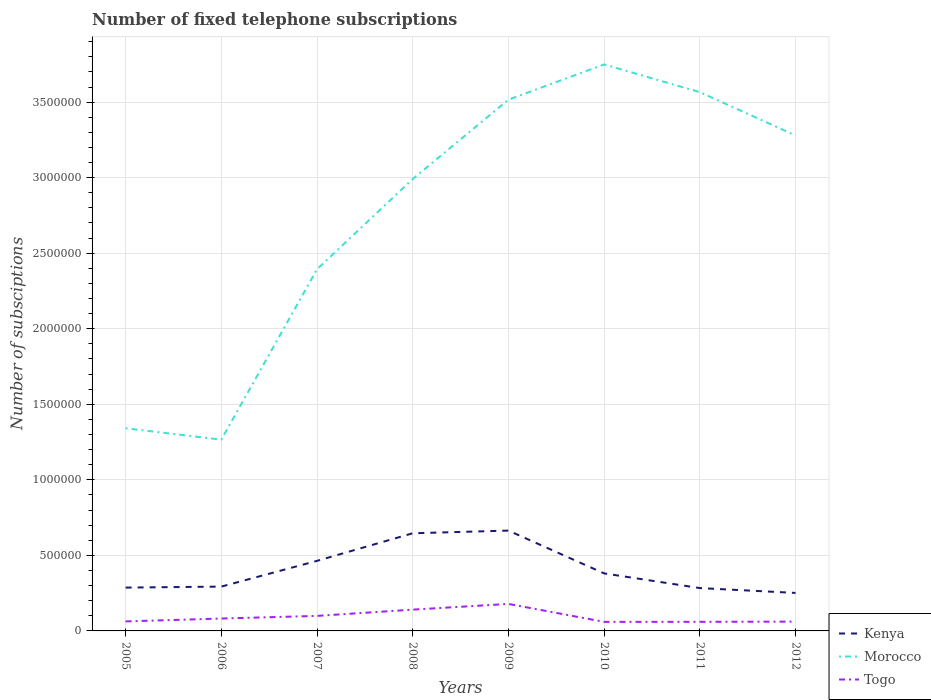Does the line corresponding to Kenya intersect with the line corresponding to Togo?
Keep it short and to the point. No. Is the number of lines equal to the number of legend labels?
Keep it short and to the point. Yes. Across all years, what is the maximum number of fixed telephone subscriptions in Morocco?
Offer a very short reply. 1.27e+06. What is the total number of fixed telephone subscriptions in Togo in the graph?
Your answer should be compact. -3.78e+04. What is the difference between the highest and the second highest number of fixed telephone subscriptions in Morocco?
Your answer should be very brief. 2.48e+06. What is the difference between the highest and the lowest number of fixed telephone subscriptions in Togo?
Your response must be concise. 3. Is the number of fixed telephone subscriptions in Kenya strictly greater than the number of fixed telephone subscriptions in Morocco over the years?
Offer a terse response. Yes. How many years are there in the graph?
Keep it short and to the point. 8. What is the difference between two consecutive major ticks on the Y-axis?
Offer a terse response. 5.00e+05. Does the graph contain any zero values?
Your response must be concise. No. How are the legend labels stacked?
Make the answer very short. Vertical. What is the title of the graph?
Your answer should be compact. Number of fixed telephone subscriptions. What is the label or title of the Y-axis?
Provide a short and direct response. Number of subsciptions. What is the Number of subsciptions in Kenya in 2005?
Provide a succinct answer. 2.87e+05. What is the Number of subsciptions in Morocco in 2005?
Offer a terse response. 1.34e+06. What is the Number of subsciptions in Togo in 2005?
Give a very brief answer. 6.28e+04. What is the Number of subsciptions of Kenya in 2006?
Offer a terse response. 2.93e+05. What is the Number of subsciptions in Morocco in 2006?
Provide a succinct answer. 1.27e+06. What is the Number of subsciptions of Togo in 2006?
Ensure brevity in your answer.  8.21e+04. What is the Number of subsciptions in Kenya in 2007?
Provide a short and direct response. 4.64e+05. What is the Number of subsciptions of Morocco in 2007?
Offer a very short reply. 2.39e+06. What is the Number of subsciptions in Togo in 2007?
Provide a short and direct response. 9.95e+04. What is the Number of subsciptions of Kenya in 2008?
Your answer should be very brief. 6.46e+05. What is the Number of subsciptions in Morocco in 2008?
Provide a short and direct response. 2.99e+06. What is the Number of subsciptions of Togo in 2008?
Your answer should be very brief. 1.41e+05. What is the Number of subsciptions in Kenya in 2009?
Offer a terse response. 6.64e+05. What is the Number of subsciptions in Morocco in 2009?
Your response must be concise. 3.52e+06. What is the Number of subsciptions in Togo in 2009?
Your answer should be compact. 1.79e+05. What is the Number of subsciptions in Kenya in 2010?
Provide a succinct answer. 3.81e+05. What is the Number of subsciptions in Morocco in 2010?
Your answer should be compact. 3.75e+06. What is the Number of subsciptions of Togo in 2010?
Give a very brief answer. 6.00e+04. What is the Number of subsciptions of Kenya in 2011?
Make the answer very short. 2.84e+05. What is the Number of subsciptions of Morocco in 2011?
Your answer should be very brief. 3.57e+06. What is the Number of subsciptions of Togo in 2011?
Your answer should be compact. 6.03e+04. What is the Number of subsciptions in Kenya in 2012?
Give a very brief answer. 2.52e+05. What is the Number of subsciptions of Morocco in 2012?
Provide a short and direct response. 3.28e+06. What is the Number of subsciptions of Togo in 2012?
Offer a terse response. 6.16e+04. Across all years, what is the maximum Number of subsciptions in Kenya?
Make the answer very short. 6.64e+05. Across all years, what is the maximum Number of subsciptions of Morocco?
Provide a short and direct response. 3.75e+06. Across all years, what is the maximum Number of subsciptions of Togo?
Provide a succinct answer. 1.79e+05. Across all years, what is the minimum Number of subsciptions of Kenya?
Provide a succinct answer. 2.52e+05. Across all years, what is the minimum Number of subsciptions in Morocco?
Provide a short and direct response. 1.27e+06. Across all years, what is the minimum Number of subsciptions of Togo?
Your answer should be very brief. 6.00e+04. What is the total Number of subsciptions of Kenya in the graph?
Keep it short and to the point. 3.27e+06. What is the total Number of subsciptions of Morocco in the graph?
Your answer should be very brief. 2.21e+07. What is the total Number of subsciptions of Togo in the graph?
Ensure brevity in your answer.  7.46e+05. What is the difference between the Number of subsciptions of Kenya in 2005 and that in 2006?
Provide a succinct answer. -6635. What is the difference between the Number of subsciptions of Morocco in 2005 and that in 2006?
Give a very brief answer. 7.50e+04. What is the difference between the Number of subsciptions in Togo in 2005 and that in 2006?
Provide a succinct answer. -1.92e+04. What is the difference between the Number of subsciptions in Kenya in 2005 and that in 2007?
Give a very brief answer. -1.77e+05. What is the difference between the Number of subsciptions of Morocco in 2005 and that in 2007?
Keep it short and to the point. -1.05e+06. What is the difference between the Number of subsciptions in Togo in 2005 and that in 2007?
Provide a succinct answer. -3.67e+04. What is the difference between the Number of subsciptions in Kenya in 2005 and that in 2008?
Provide a short and direct response. -3.60e+05. What is the difference between the Number of subsciptions of Morocco in 2005 and that in 2008?
Make the answer very short. -1.65e+06. What is the difference between the Number of subsciptions of Togo in 2005 and that in 2008?
Your response must be concise. -7.81e+04. What is the difference between the Number of subsciptions in Kenya in 2005 and that in 2009?
Offer a very short reply. -3.77e+05. What is the difference between the Number of subsciptions in Morocco in 2005 and that in 2009?
Provide a short and direct response. -2.18e+06. What is the difference between the Number of subsciptions of Togo in 2005 and that in 2009?
Offer a very short reply. -1.16e+05. What is the difference between the Number of subsciptions in Kenya in 2005 and that in 2010?
Your response must be concise. -9.40e+04. What is the difference between the Number of subsciptions in Morocco in 2005 and that in 2010?
Your answer should be compact. -2.41e+06. What is the difference between the Number of subsciptions in Togo in 2005 and that in 2010?
Your answer should be compact. 2820. What is the difference between the Number of subsciptions of Kenya in 2005 and that in 2011?
Your answer should be compact. 3183. What is the difference between the Number of subsciptions of Morocco in 2005 and that in 2011?
Provide a succinct answer. -2.22e+06. What is the difference between the Number of subsciptions in Togo in 2005 and that in 2011?
Provide a short and direct response. 2558. What is the difference between the Number of subsciptions of Kenya in 2005 and that in 2012?
Your answer should be compact. 3.52e+04. What is the difference between the Number of subsciptions in Morocco in 2005 and that in 2012?
Your response must be concise. -1.94e+06. What is the difference between the Number of subsciptions of Togo in 2005 and that in 2012?
Provide a succinct answer. 1241. What is the difference between the Number of subsciptions of Kenya in 2006 and that in 2007?
Your answer should be very brief. -1.70e+05. What is the difference between the Number of subsciptions in Morocco in 2006 and that in 2007?
Your answer should be very brief. -1.13e+06. What is the difference between the Number of subsciptions of Togo in 2006 and that in 2007?
Make the answer very short. -1.74e+04. What is the difference between the Number of subsciptions of Kenya in 2006 and that in 2008?
Offer a very short reply. -3.53e+05. What is the difference between the Number of subsciptions of Morocco in 2006 and that in 2008?
Your answer should be compact. -1.73e+06. What is the difference between the Number of subsciptions of Togo in 2006 and that in 2008?
Offer a very short reply. -5.89e+04. What is the difference between the Number of subsciptions of Kenya in 2006 and that in 2009?
Your answer should be compact. -3.71e+05. What is the difference between the Number of subsciptions of Morocco in 2006 and that in 2009?
Your answer should be very brief. -2.25e+06. What is the difference between the Number of subsciptions of Togo in 2006 and that in 2009?
Ensure brevity in your answer.  -9.67e+04. What is the difference between the Number of subsciptions in Kenya in 2006 and that in 2010?
Keep it short and to the point. -8.74e+04. What is the difference between the Number of subsciptions in Morocco in 2006 and that in 2010?
Keep it short and to the point. -2.48e+06. What is the difference between the Number of subsciptions of Togo in 2006 and that in 2010?
Give a very brief answer. 2.20e+04. What is the difference between the Number of subsciptions in Kenya in 2006 and that in 2011?
Ensure brevity in your answer.  9818. What is the difference between the Number of subsciptions in Morocco in 2006 and that in 2011?
Your response must be concise. -2.30e+06. What is the difference between the Number of subsciptions of Togo in 2006 and that in 2011?
Provide a short and direct response. 2.18e+04. What is the difference between the Number of subsciptions in Kenya in 2006 and that in 2012?
Offer a terse response. 4.18e+04. What is the difference between the Number of subsciptions of Morocco in 2006 and that in 2012?
Ensure brevity in your answer.  -2.01e+06. What is the difference between the Number of subsciptions of Togo in 2006 and that in 2012?
Give a very brief answer. 2.05e+04. What is the difference between the Number of subsciptions of Kenya in 2007 and that in 2008?
Give a very brief answer. -1.83e+05. What is the difference between the Number of subsciptions of Morocco in 2007 and that in 2008?
Your response must be concise. -5.97e+05. What is the difference between the Number of subsciptions in Togo in 2007 and that in 2008?
Offer a terse response. -4.14e+04. What is the difference between the Number of subsciptions in Kenya in 2007 and that in 2009?
Keep it short and to the point. -2.00e+05. What is the difference between the Number of subsciptions of Morocco in 2007 and that in 2009?
Your response must be concise. -1.12e+06. What is the difference between the Number of subsciptions in Togo in 2007 and that in 2009?
Your answer should be compact. -7.92e+04. What is the difference between the Number of subsciptions in Kenya in 2007 and that in 2010?
Your answer should be compact. 8.30e+04. What is the difference between the Number of subsciptions of Morocco in 2007 and that in 2010?
Provide a short and direct response. -1.36e+06. What is the difference between the Number of subsciptions of Togo in 2007 and that in 2010?
Your response must be concise. 3.95e+04. What is the difference between the Number of subsciptions of Kenya in 2007 and that in 2011?
Offer a very short reply. 1.80e+05. What is the difference between the Number of subsciptions of Morocco in 2007 and that in 2011?
Your answer should be very brief. -1.17e+06. What is the difference between the Number of subsciptions of Togo in 2007 and that in 2011?
Keep it short and to the point. 3.92e+04. What is the difference between the Number of subsciptions of Kenya in 2007 and that in 2012?
Your response must be concise. 2.12e+05. What is the difference between the Number of subsciptions in Morocco in 2007 and that in 2012?
Provide a short and direct response. -8.85e+05. What is the difference between the Number of subsciptions in Togo in 2007 and that in 2012?
Your response must be concise. 3.79e+04. What is the difference between the Number of subsciptions in Kenya in 2008 and that in 2009?
Your response must be concise. -1.77e+04. What is the difference between the Number of subsciptions of Morocco in 2008 and that in 2009?
Provide a succinct answer. -5.25e+05. What is the difference between the Number of subsciptions in Togo in 2008 and that in 2009?
Offer a very short reply. -3.78e+04. What is the difference between the Number of subsciptions of Kenya in 2008 and that in 2010?
Offer a very short reply. 2.66e+05. What is the difference between the Number of subsciptions in Morocco in 2008 and that in 2010?
Provide a succinct answer. -7.58e+05. What is the difference between the Number of subsciptions of Togo in 2008 and that in 2010?
Your answer should be very brief. 8.09e+04. What is the difference between the Number of subsciptions in Kenya in 2008 and that in 2011?
Your response must be concise. 3.63e+05. What is the difference between the Number of subsciptions of Morocco in 2008 and that in 2011?
Give a very brief answer. -5.75e+05. What is the difference between the Number of subsciptions in Togo in 2008 and that in 2011?
Give a very brief answer. 8.06e+04. What is the difference between the Number of subsciptions in Kenya in 2008 and that in 2012?
Offer a very short reply. 3.95e+05. What is the difference between the Number of subsciptions in Morocco in 2008 and that in 2012?
Offer a terse response. -2.88e+05. What is the difference between the Number of subsciptions in Togo in 2008 and that in 2012?
Your answer should be compact. 7.93e+04. What is the difference between the Number of subsciptions of Kenya in 2009 and that in 2010?
Ensure brevity in your answer.  2.83e+05. What is the difference between the Number of subsciptions of Morocco in 2009 and that in 2010?
Keep it short and to the point. -2.33e+05. What is the difference between the Number of subsciptions of Togo in 2009 and that in 2010?
Offer a terse response. 1.19e+05. What is the difference between the Number of subsciptions of Kenya in 2009 and that in 2011?
Keep it short and to the point. 3.81e+05. What is the difference between the Number of subsciptions in Morocco in 2009 and that in 2011?
Ensure brevity in your answer.  -4.98e+04. What is the difference between the Number of subsciptions of Togo in 2009 and that in 2011?
Your answer should be compact. 1.18e+05. What is the difference between the Number of subsciptions in Kenya in 2009 and that in 2012?
Provide a succinct answer. 4.13e+05. What is the difference between the Number of subsciptions in Morocco in 2009 and that in 2012?
Provide a short and direct response. 2.37e+05. What is the difference between the Number of subsciptions of Togo in 2009 and that in 2012?
Ensure brevity in your answer.  1.17e+05. What is the difference between the Number of subsciptions of Kenya in 2010 and that in 2011?
Give a very brief answer. 9.72e+04. What is the difference between the Number of subsciptions in Morocco in 2010 and that in 2011?
Offer a terse response. 1.83e+05. What is the difference between the Number of subsciptions in Togo in 2010 and that in 2011?
Offer a terse response. -262. What is the difference between the Number of subsciptions of Kenya in 2010 and that in 2012?
Offer a terse response. 1.29e+05. What is the difference between the Number of subsciptions in Morocco in 2010 and that in 2012?
Offer a very short reply. 4.70e+05. What is the difference between the Number of subsciptions of Togo in 2010 and that in 2012?
Your answer should be very brief. -1579. What is the difference between the Number of subsciptions of Kenya in 2011 and that in 2012?
Offer a very short reply. 3.20e+04. What is the difference between the Number of subsciptions of Morocco in 2011 and that in 2012?
Offer a terse response. 2.87e+05. What is the difference between the Number of subsciptions in Togo in 2011 and that in 2012?
Provide a succinct answer. -1317. What is the difference between the Number of subsciptions in Kenya in 2005 and the Number of subsciptions in Morocco in 2006?
Give a very brief answer. -9.79e+05. What is the difference between the Number of subsciptions in Kenya in 2005 and the Number of subsciptions in Togo in 2006?
Offer a terse response. 2.05e+05. What is the difference between the Number of subsciptions in Morocco in 2005 and the Number of subsciptions in Togo in 2006?
Your response must be concise. 1.26e+06. What is the difference between the Number of subsciptions in Kenya in 2005 and the Number of subsciptions in Morocco in 2007?
Provide a short and direct response. -2.11e+06. What is the difference between the Number of subsciptions in Kenya in 2005 and the Number of subsciptions in Togo in 2007?
Make the answer very short. 1.87e+05. What is the difference between the Number of subsciptions of Morocco in 2005 and the Number of subsciptions of Togo in 2007?
Make the answer very short. 1.24e+06. What is the difference between the Number of subsciptions of Kenya in 2005 and the Number of subsciptions of Morocco in 2008?
Your response must be concise. -2.70e+06. What is the difference between the Number of subsciptions in Kenya in 2005 and the Number of subsciptions in Togo in 2008?
Provide a succinct answer. 1.46e+05. What is the difference between the Number of subsciptions in Morocco in 2005 and the Number of subsciptions in Togo in 2008?
Offer a terse response. 1.20e+06. What is the difference between the Number of subsciptions in Kenya in 2005 and the Number of subsciptions in Morocco in 2009?
Give a very brief answer. -3.23e+06. What is the difference between the Number of subsciptions of Kenya in 2005 and the Number of subsciptions of Togo in 2009?
Ensure brevity in your answer.  1.08e+05. What is the difference between the Number of subsciptions in Morocco in 2005 and the Number of subsciptions in Togo in 2009?
Keep it short and to the point. 1.16e+06. What is the difference between the Number of subsciptions of Kenya in 2005 and the Number of subsciptions of Morocco in 2010?
Your response must be concise. -3.46e+06. What is the difference between the Number of subsciptions in Kenya in 2005 and the Number of subsciptions in Togo in 2010?
Your answer should be compact. 2.27e+05. What is the difference between the Number of subsciptions in Morocco in 2005 and the Number of subsciptions in Togo in 2010?
Ensure brevity in your answer.  1.28e+06. What is the difference between the Number of subsciptions of Kenya in 2005 and the Number of subsciptions of Morocco in 2011?
Make the answer very short. -3.28e+06. What is the difference between the Number of subsciptions of Kenya in 2005 and the Number of subsciptions of Togo in 2011?
Offer a very short reply. 2.26e+05. What is the difference between the Number of subsciptions of Morocco in 2005 and the Number of subsciptions of Togo in 2011?
Offer a very short reply. 1.28e+06. What is the difference between the Number of subsciptions of Kenya in 2005 and the Number of subsciptions of Morocco in 2012?
Make the answer very short. -2.99e+06. What is the difference between the Number of subsciptions of Kenya in 2005 and the Number of subsciptions of Togo in 2012?
Your answer should be compact. 2.25e+05. What is the difference between the Number of subsciptions in Morocco in 2005 and the Number of subsciptions in Togo in 2012?
Keep it short and to the point. 1.28e+06. What is the difference between the Number of subsciptions in Kenya in 2006 and the Number of subsciptions in Morocco in 2007?
Your response must be concise. -2.10e+06. What is the difference between the Number of subsciptions in Kenya in 2006 and the Number of subsciptions in Togo in 2007?
Offer a terse response. 1.94e+05. What is the difference between the Number of subsciptions in Morocco in 2006 and the Number of subsciptions in Togo in 2007?
Ensure brevity in your answer.  1.17e+06. What is the difference between the Number of subsciptions in Kenya in 2006 and the Number of subsciptions in Morocco in 2008?
Offer a terse response. -2.70e+06. What is the difference between the Number of subsciptions of Kenya in 2006 and the Number of subsciptions of Togo in 2008?
Offer a terse response. 1.52e+05. What is the difference between the Number of subsciptions of Morocco in 2006 and the Number of subsciptions of Togo in 2008?
Offer a very short reply. 1.13e+06. What is the difference between the Number of subsciptions in Kenya in 2006 and the Number of subsciptions in Morocco in 2009?
Your answer should be compact. -3.22e+06. What is the difference between the Number of subsciptions of Kenya in 2006 and the Number of subsciptions of Togo in 2009?
Offer a terse response. 1.15e+05. What is the difference between the Number of subsciptions in Morocco in 2006 and the Number of subsciptions in Togo in 2009?
Your answer should be very brief. 1.09e+06. What is the difference between the Number of subsciptions of Kenya in 2006 and the Number of subsciptions of Morocco in 2010?
Your response must be concise. -3.46e+06. What is the difference between the Number of subsciptions of Kenya in 2006 and the Number of subsciptions of Togo in 2010?
Your answer should be compact. 2.33e+05. What is the difference between the Number of subsciptions of Morocco in 2006 and the Number of subsciptions of Togo in 2010?
Give a very brief answer. 1.21e+06. What is the difference between the Number of subsciptions of Kenya in 2006 and the Number of subsciptions of Morocco in 2011?
Ensure brevity in your answer.  -3.27e+06. What is the difference between the Number of subsciptions of Kenya in 2006 and the Number of subsciptions of Togo in 2011?
Your response must be concise. 2.33e+05. What is the difference between the Number of subsciptions of Morocco in 2006 and the Number of subsciptions of Togo in 2011?
Offer a very short reply. 1.21e+06. What is the difference between the Number of subsciptions in Kenya in 2006 and the Number of subsciptions in Morocco in 2012?
Provide a succinct answer. -2.99e+06. What is the difference between the Number of subsciptions in Kenya in 2006 and the Number of subsciptions in Togo in 2012?
Provide a succinct answer. 2.32e+05. What is the difference between the Number of subsciptions in Morocco in 2006 and the Number of subsciptions in Togo in 2012?
Give a very brief answer. 1.20e+06. What is the difference between the Number of subsciptions of Kenya in 2007 and the Number of subsciptions of Morocco in 2008?
Your answer should be compact. -2.53e+06. What is the difference between the Number of subsciptions of Kenya in 2007 and the Number of subsciptions of Togo in 2008?
Keep it short and to the point. 3.23e+05. What is the difference between the Number of subsciptions in Morocco in 2007 and the Number of subsciptions in Togo in 2008?
Ensure brevity in your answer.  2.25e+06. What is the difference between the Number of subsciptions in Kenya in 2007 and the Number of subsciptions in Morocco in 2009?
Provide a succinct answer. -3.05e+06. What is the difference between the Number of subsciptions in Kenya in 2007 and the Number of subsciptions in Togo in 2009?
Your answer should be compact. 2.85e+05. What is the difference between the Number of subsciptions of Morocco in 2007 and the Number of subsciptions of Togo in 2009?
Your response must be concise. 2.22e+06. What is the difference between the Number of subsciptions in Kenya in 2007 and the Number of subsciptions in Morocco in 2010?
Give a very brief answer. -3.29e+06. What is the difference between the Number of subsciptions in Kenya in 2007 and the Number of subsciptions in Togo in 2010?
Offer a terse response. 4.04e+05. What is the difference between the Number of subsciptions in Morocco in 2007 and the Number of subsciptions in Togo in 2010?
Keep it short and to the point. 2.33e+06. What is the difference between the Number of subsciptions in Kenya in 2007 and the Number of subsciptions in Morocco in 2011?
Provide a succinct answer. -3.10e+06. What is the difference between the Number of subsciptions of Kenya in 2007 and the Number of subsciptions of Togo in 2011?
Your answer should be compact. 4.03e+05. What is the difference between the Number of subsciptions in Morocco in 2007 and the Number of subsciptions in Togo in 2011?
Your answer should be compact. 2.33e+06. What is the difference between the Number of subsciptions in Kenya in 2007 and the Number of subsciptions in Morocco in 2012?
Offer a terse response. -2.82e+06. What is the difference between the Number of subsciptions of Kenya in 2007 and the Number of subsciptions of Togo in 2012?
Make the answer very short. 4.02e+05. What is the difference between the Number of subsciptions in Morocco in 2007 and the Number of subsciptions in Togo in 2012?
Provide a succinct answer. 2.33e+06. What is the difference between the Number of subsciptions in Kenya in 2008 and the Number of subsciptions in Morocco in 2009?
Your response must be concise. -2.87e+06. What is the difference between the Number of subsciptions in Kenya in 2008 and the Number of subsciptions in Togo in 2009?
Make the answer very short. 4.68e+05. What is the difference between the Number of subsciptions in Morocco in 2008 and the Number of subsciptions in Togo in 2009?
Give a very brief answer. 2.81e+06. What is the difference between the Number of subsciptions in Kenya in 2008 and the Number of subsciptions in Morocco in 2010?
Offer a terse response. -3.10e+06. What is the difference between the Number of subsciptions in Kenya in 2008 and the Number of subsciptions in Togo in 2010?
Keep it short and to the point. 5.86e+05. What is the difference between the Number of subsciptions of Morocco in 2008 and the Number of subsciptions of Togo in 2010?
Make the answer very short. 2.93e+06. What is the difference between the Number of subsciptions in Kenya in 2008 and the Number of subsciptions in Morocco in 2011?
Your answer should be very brief. -2.92e+06. What is the difference between the Number of subsciptions of Kenya in 2008 and the Number of subsciptions of Togo in 2011?
Offer a terse response. 5.86e+05. What is the difference between the Number of subsciptions of Morocco in 2008 and the Number of subsciptions of Togo in 2011?
Keep it short and to the point. 2.93e+06. What is the difference between the Number of subsciptions of Kenya in 2008 and the Number of subsciptions of Morocco in 2012?
Your answer should be compact. -2.63e+06. What is the difference between the Number of subsciptions of Kenya in 2008 and the Number of subsciptions of Togo in 2012?
Your answer should be compact. 5.85e+05. What is the difference between the Number of subsciptions of Morocco in 2008 and the Number of subsciptions of Togo in 2012?
Your answer should be compact. 2.93e+06. What is the difference between the Number of subsciptions of Kenya in 2009 and the Number of subsciptions of Morocco in 2010?
Your response must be concise. -3.09e+06. What is the difference between the Number of subsciptions in Kenya in 2009 and the Number of subsciptions in Togo in 2010?
Your response must be concise. 6.04e+05. What is the difference between the Number of subsciptions in Morocco in 2009 and the Number of subsciptions in Togo in 2010?
Make the answer very short. 3.46e+06. What is the difference between the Number of subsciptions in Kenya in 2009 and the Number of subsciptions in Morocco in 2011?
Keep it short and to the point. -2.90e+06. What is the difference between the Number of subsciptions of Kenya in 2009 and the Number of subsciptions of Togo in 2011?
Your answer should be compact. 6.04e+05. What is the difference between the Number of subsciptions in Morocco in 2009 and the Number of subsciptions in Togo in 2011?
Your response must be concise. 3.46e+06. What is the difference between the Number of subsciptions in Kenya in 2009 and the Number of subsciptions in Morocco in 2012?
Provide a succinct answer. -2.61e+06. What is the difference between the Number of subsciptions in Kenya in 2009 and the Number of subsciptions in Togo in 2012?
Provide a short and direct response. 6.03e+05. What is the difference between the Number of subsciptions of Morocco in 2009 and the Number of subsciptions of Togo in 2012?
Give a very brief answer. 3.45e+06. What is the difference between the Number of subsciptions in Kenya in 2010 and the Number of subsciptions in Morocco in 2011?
Keep it short and to the point. -3.19e+06. What is the difference between the Number of subsciptions in Kenya in 2010 and the Number of subsciptions in Togo in 2011?
Keep it short and to the point. 3.20e+05. What is the difference between the Number of subsciptions of Morocco in 2010 and the Number of subsciptions of Togo in 2011?
Give a very brief answer. 3.69e+06. What is the difference between the Number of subsciptions of Kenya in 2010 and the Number of subsciptions of Morocco in 2012?
Your response must be concise. -2.90e+06. What is the difference between the Number of subsciptions of Kenya in 2010 and the Number of subsciptions of Togo in 2012?
Provide a succinct answer. 3.19e+05. What is the difference between the Number of subsciptions of Morocco in 2010 and the Number of subsciptions of Togo in 2012?
Keep it short and to the point. 3.69e+06. What is the difference between the Number of subsciptions of Kenya in 2011 and the Number of subsciptions of Morocco in 2012?
Offer a terse response. -3.00e+06. What is the difference between the Number of subsciptions in Kenya in 2011 and the Number of subsciptions in Togo in 2012?
Your answer should be compact. 2.22e+05. What is the difference between the Number of subsciptions of Morocco in 2011 and the Number of subsciptions of Togo in 2012?
Make the answer very short. 3.50e+06. What is the average Number of subsciptions in Kenya per year?
Provide a short and direct response. 4.09e+05. What is the average Number of subsciptions in Morocco per year?
Ensure brevity in your answer.  2.76e+06. What is the average Number of subsciptions in Togo per year?
Make the answer very short. 9.32e+04. In the year 2005, what is the difference between the Number of subsciptions of Kenya and Number of subsciptions of Morocco?
Make the answer very short. -1.05e+06. In the year 2005, what is the difference between the Number of subsciptions in Kenya and Number of subsciptions in Togo?
Your answer should be very brief. 2.24e+05. In the year 2005, what is the difference between the Number of subsciptions in Morocco and Number of subsciptions in Togo?
Keep it short and to the point. 1.28e+06. In the year 2006, what is the difference between the Number of subsciptions of Kenya and Number of subsciptions of Morocco?
Your answer should be compact. -9.73e+05. In the year 2006, what is the difference between the Number of subsciptions in Kenya and Number of subsciptions in Togo?
Provide a succinct answer. 2.11e+05. In the year 2006, what is the difference between the Number of subsciptions in Morocco and Number of subsciptions in Togo?
Keep it short and to the point. 1.18e+06. In the year 2007, what is the difference between the Number of subsciptions in Kenya and Number of subsciptions in Morocco?
Your response must be concise. -1.93e+06. In the year 2007, what is the difference between the Number of subsciptions of Kenya and Number of subsciptions of Togo?
Your response must be concise. 3.64e+05. In the year 2007, what is the difference between the Number of subsciptions in Morocco and Number of subsciptions in Togo?
Make the answer very short. 2.29e+06. In the year 2008, what is the difference between the Number of subsciptions of Kenya and Number of subsciptions of Morocco?
Your answer should be very brief. -2.34e+06. In the year 2008, what is the difference between the Number of subsciptions of Kenya and Number of subsciptions of Togo?
Keep it short and to the point. 5.05e+05. In the year 2008, what is the difference between the Number of subsciptions of Morocco and Number of subsciptions of Togo?
Make the answer very short. 2.85e+06. In the year 2009, what is the difference between the Number of subsciptions in Kenya and Number of subsciptions in Morocco?
Ensure brevity in your answer.  -2.85e+06. In the year 2009, what is the difference between the Number of subsciptions in Kenya and Number of subsciptions in Togo?
Provide a succinct answer. 4.85e+05. In the year 2009, what is the difference between the Number of subsciptions in Morocco and Number of subsciptions in Togo?
Your response must be concise. 3.34e+06. In the year 2010, what is the difference between the Number of subsciptions of Kenya and Number of subsciptions of Morocco?
Offer a terse response. -3.37e+06. In the year 2010, what is the difference between the Number of subsciptions in Kenya and Number of subsciptions in Togo?
Ensure brevity in your answer.  3.21e+05. In the year 2010, what is the difference between the Number of subsciptions of Morocco and Number of subsciptions of Togo?
Ensure brevity in your answer.  3.69e+06. In the year 2011, what is the difference between the Number of subsciptions of Kenya and Number of subsciptions of Morocco?
Your response must be concise. -3.28e+06. In the year 2011, what is the difference between the Number of subsciptions of Kenya and Number of subsciptions of Togo?
Provide a short and direct response. 2.23e+05. In the year 2011, what is the difference between the Number of subsciptions in Morocco and Number of subsciptions in Togo?
Ensure brevity in your answer.  3.51e+06. In the year 2012, what is the difference between the Number of subsciptions of Kenya and Number of subsciptions of Morocco?
Provide a succinct answer. -3.03e+06. In the year 2012, what is the difference between the Number of subsciptions in Kenya and Number of subsciptions in Togo?
Your answer should be very brief. 1.90e+05. In the year 2012, what is the difference between the Number of subsciptions in Morocco and Number of subsciptions in Togo?
Your answer should be compact. 3.22e+06. What is the ratio of the Number of subsciptions in Kenya in 2005 to that in 2006?
Your answer should be compact. 0.98. What is the ratio of the Number of subsciptions in Morocco in 2005 to that in 2006?
Keep it short and to the point. 1.06. What is the ratio of the Number of subsciptions of Togo in 2005 to that in 2006?
Provide a short and direct response. 0.77. What is the ratio of the Number of subsciptions in Kenya in 2005 to that in 2007?
Offer a terse response. 0.62. What is the ratio of the Number of subsciptions in Morocco in 2005 to that in 2007?
Ensure brevity in your answer.  0.56. What is the ratio of the Number of subsciptions in Togo in 2005 to that in 2007?
Your response must be concise. 0.63. What is the ratio of the Number of subsciptions in Kenya in 2005 to that in 2008?
Offer a terse response. 0.44. What is the ratio of the Number of subsciptions in Morocco in 2005 to that in 2008?
Make the answer very short. 0.45. What is the ratio of the Number of subsciptions of Togo in 2005 to that in 2008?
Provide a succinct answer. 0.45. What is the ratio of the Number of subsciptions of Kenya in 2005 to that in 2009?
Offer a very short reply. 0.43. What is the ratio of the Number of subsciptions of Morocco in 2005 to that in 2009?
Your answer should be compact. 0.38. What is the ratio of the Number of subsciptions in Togo in 2005 to that in 2009?
Keep it short and to the point. 0.35. What is the ratio of the Number of subsciptions in Kenya in 2005 to that in 2010?
Keep it short and to the point. 0.75. What is the ratio of the Number of subsciptions in Morocco in 2005 to that in 2010?
Your answer should be compact. 0.36. What is the ratio of the Number of subsciptions in Togo in 2005 to that in 2010?
Your response must be concise. 1.05. What is the ratio of the Number of subsciptions of Kenya in 2005 to that in 2011?
Your answer should be very brief. 1.01. What is the ratio of the Number of subsciptions of Morocco in 2005 to that in 2011?
Give a very brief answer. 0.38. What is the ratio of the Number of subsciptions in Togo in 2005 to that in 2011?
Your answer should be very brief. 1.04. What is the ratio of the Number of subsciptions in Kenya in 2005 to that in 2012?
Keep it short and to the point. 1.14. What is the ratio of the Number of subsciptions in Morocco in 2005 to that in 2012?
Offer a terse response. 0.41. What is the ratio of the Number of subsciptions of Togo in 2005 to that in 2012?
Your answer should be compact. 1.02. What is the ratio of the Number of subsciptions of Kenya in 2006 to that in 2007?
Offer a very short reply. 0.63. What is the ratio of the Number of subsciptions of Morocco in 2006 to that in 2007?
Provide a succinct answer. 0.53. What is the ratio of the Number of subsciptions in Togo in 2006 to that in 2007?
Make the answer very short. 0.82. What is the ratio of the Number of subsciptions in Kenya in 2006 to that in 2008?
Your answer should be very brief. 0.45. What is the ratio of the Number of subsciptions in Morocco in 2006 to that in 2008?
Ensure brevity in your answer.  0.42. What is the ratio of the Number of subsciptions in Togo in 2006 to that in 2008?
Give a very brief answer. 0.58. What is the ratio of the Number of subsciptions of Kenya in 2006 to that in 2009?
Keep it short and to the point. 0.44. What is the ratio of the Number of subsciptions in Morocco in 2006 to that in 2009?
Your answer should be very brief. 0.36. What is the ratio of the Number of subsciptions in Togo in 2006 to that in 2009?
Keep it short and to the point. 0.46. What is the ratio of the Number of subsciptions of Kenya in 2006 to that in 2010?
Your response must be concise. 0.77. What is the ratio of the Number of subsciptions of Morocco in 2006 to that in 2010?
Offer a terse response. 0.34. What is the ratio of the Number of subsciptions in Togo in 2006 to that in 2010?
Provide a short and direct response. 1.37. What is the ratio of the Number of subsciptions of Kenya in 2006 to that in 2011?
Your answer should be compact. 1.03. What is the ratio of the Number of subsciptions of Morocco in 2006 to that in 2011?
Your answer should be very brief. 0.35. What is the ratio of the Number of subsciptions of Togo in 2006 to that in 2011?
Give a very brief answer. 1.36. What is the ratio of the Number of subsciptions of Kenya in 2006 to that in 2012?
Keep it short and to the point. 1.17. What is the ratio of the Number of subsciptions of Morocco in 2006 to that in 2012?
Your answer should be very brief. 0.39. What is the ratio of the Number of subsciptions in Togo in 2006 to that in 2012?
Offer a very short reply. 1.33. What is the ratio of the Number of subsciptions in Kenya in 2007 to that in 2008?
Ensure brevity in your answer.  0.72. What is the ratio of the Number of subsciptions in Morocco in 2007 to that in 2008?
Ensure brevity in your answer.  0.8. What is the ratio of the Number of subsciptions in Togo in 2007 to that in 2008?
Offer a very short reply. 0.71. What is the ratio of the Number of subsciptions in Kenya in 2007 to that in 2009?
Provide a succinct answer. 0.7. What is the ratio of the Number of subsciptions of Morocco in 2007 to that in 2009?
Keep it short and to the point. 0.68. What is the ratio of the Number of subsciptions in Togo in 2007 to that in 2009?
Offer a terse response. 0.56. What is the ratio of the Number of subsciptions of Kenya in 2007 to that in 2010?
Provide a succinct answer. 1.22. What is the ratio of the Number of subsciptions in Morocco in 2007 to that in 2010?
Your answer should be compact. 0.64. What is the ratio of the Number of subsciptions in Togo in 2007 to that in 2010?
Provide a short and direct response. 1.66. What is the ratio of the Number of subsciptions of Kenya in 2007 to that in 2011?
Your response must be concise. 1.64. What is the ratio of the Number of subsciptions in Morocco in 2007 to that in 2011?
Give a very brief answer. 0.67. What is the ratio of the Number of subsciptions in Togo in 2007 to that in 2011?
Provide a short and direct response. 1.65. What is the ratio of the Number of subsciptions in Kenya in 2007 to that in 2012?
Offer a very short reply. 1.84. What is the ratio of the Number of subsciptions in Morocco in 2007 to that in 2012?
Make the answer very short. 0.73. What is the ratio of the Number of subsciptions in Togo in 2007 to that in 2012?
Ensure brevity in your answer.  1.62. What is the ratio of the Number of subsciptions of Kenya in 2008 to that in 2009?
Give a very brief answer. 0.97. What is the ratio of the Number of subsciptions in Morocco in 2008 to that in 2009?
Provide a short and direct response. 0.85. What is the ratio of the Number of subsciptions of Togo in 2008 to that in 2009?
Provide a short and direct response. 0.79. What is the ratio of the Number of subsciptions of Kenya in 2008 to that in 2010?
Your answer should be very brief. 1.7. What is the ratio of the Number of subsciptions in Morocco in 2008 to that in 2010?
Give a very brief answer. 0.8. What is the ratio of the Number of subsciptions in Togo in 2008 to that in 2010?
Your response must be concise. 2.35. What is the ratio of the Number of subsciptions in Kenya in 2008 to that in 2011?
Make the answer very short. 2.28. What is the ratio of the Number of subsciptions of Morocco in 2008 to that in 2011?
Offer a terse response. 0.84. What is the ratio of the Number of subsciptions in Togo in 2008 to that in 2011?
Offer a very short reply. 2.34. What is the ratio of the Number of subsciptions in Kenya in 2008 to that in 2012?
Ensure brevity in your answer.  2.57. What is the ratio of the Number of subsciptions in Morocco in 2008 to that in 2012?
Offer a very short reply. 0.91. What is the ratio of the Number of subsciptions in Togo in 2008 to that in 2012?
Keep it short and to the point. 2.29. What is the ratio of the Number of subsciptions of Kenya in 2009 to that in 2010?
Your answer should be very brief. 1.74. What is the ratio of the Number of subsciptions of Morocco in 2009 to that in 2010?
Provide a short and direct response. 0.94. What is the ratio of the Number of subsciptions of Togo in 2009 to that in 2010?
Offer a terse response. 2.98. What is the ratio of the Number of subsciptions of Kenya in 2009 to that in 2011?
Your answer should be very brief. 2.34. What is the ratio of the Number of subsciptions of Togo in 2009 to that in 2011?
Give a very brief answer. 2.97. What is the ratio of the Number of subsciptions of Kenya in 2009 to that in 2012?
Ensure brevity in your answer.  2.64. What is the ratio of the Number of subsciptions in Morocco in 2009 to that in 2012?
Your answer should be very brief. 1.07. What is the ratio of the Number of subsciptions in Togo in 2009 to that in 2012?
Provide a succinct answer. 2.9. What is the ratio of the Number of subsciptions in Kenya in 2010 to that in 2011?
Your response must be concise. 1.34. What is the ratio of the Number of subsciptions of Morocco in 2010 to that in 2011?
Provide a short and direct response. 1.05. What is the ratio of the Number of subsciptions in Kenya in 2010 to that in 2012?
Offer a very short reply. 1.51. What is the ratio of the Number of subsciptions in Morocco in 2010 to that in 2012?
Your response must be concise. 1.14. What is the ratio of the Number of subsciptions in Togo in 2010 to that in 2012?
Ensure brevity in your answer.  0.97. What is the ratio of the Number of subsciptions in Kenya in 2011 to that in 2012?
Offer a very short reply. 1.13. What is the ratio of the Number of subsciptions in Morocco in 2011 to that in 2012?
Keep it short and to the point. 1.09. What is the ratio of the Number of subsciptions of Togo in 2011 to that in 2012?
Provide a short and direct response. 0.98. What is the difference between the highest and the second highest Number of subsciptions in Kenya?
Your response must be concise. 1.77e+04. What is the difference between the highest and the second highest Number of subsciptions in Morocco?
Provide a short and direct response. 1.83e+05. What is the difference between the highest and the second highest Number of subsciptions in Togo?
Your answer should be compact. 3.78e+04. What is the difference between the highest and the lowest Number of subsciptions in Kenya?
Keep it short and to the point. 4.13e+05. What is the difference between the highest and the lowest Number of subsciptions in Morocco?
Make the answer very short. 2.48e+06. What is the difference between the highest and the lowest Number of subsciptions in Togo?
Your answer should be very brief. 1.19e+05. 